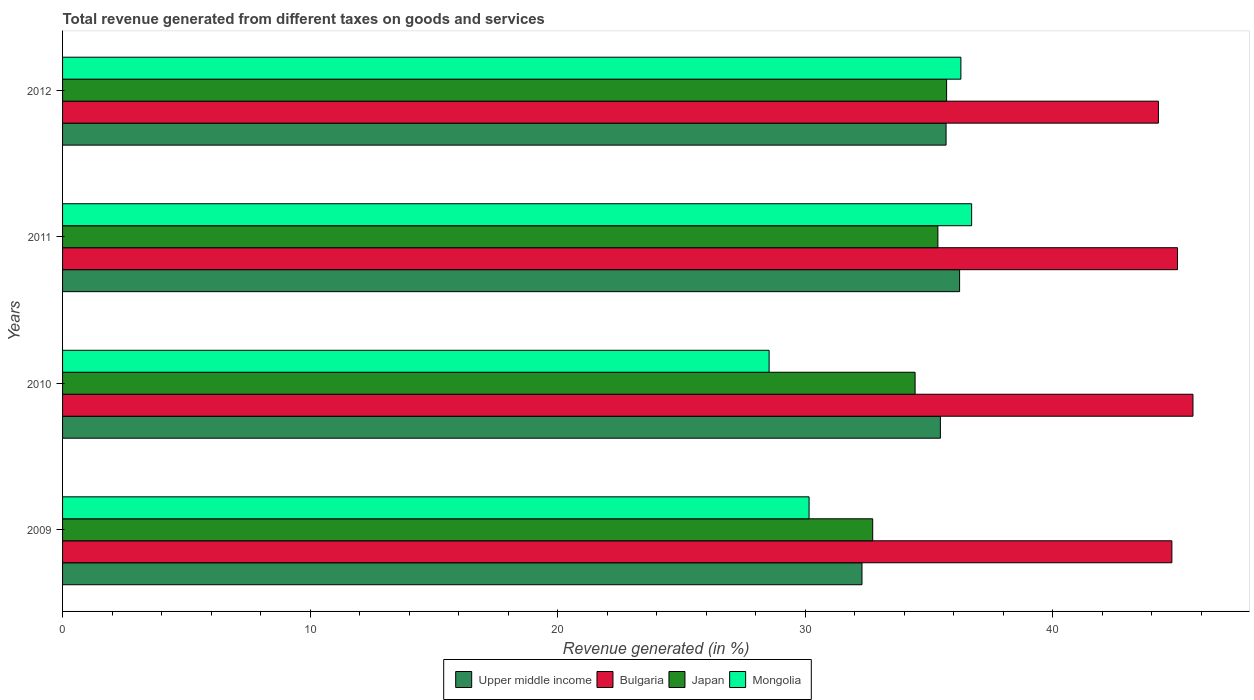How many different coloured bars are there?
Offer a terse response. 4. How many groups of bars are there?
Your answer should be compact. 4. Are the number of bars per tick equal to the number of legend labels?
Offer a very short reply. Yes. Are the number of bars on each tick of the Y-axis equal?
Your response must be concise. Yes. How many bars are there on the 3rd tick from the bottom?
Give a very brief answer. 4. What is the label of the 3rd group of bars from the top?
Offer a terse response. 2010. What is the total revenue generated in Bulgaria in 2010?
Ensure brevity in your answer.  45.67. Across all years, what is the maximum total revenue generated in Upper middle income?
Make the answer very short. 36.24. Across all years, what is the minimum total revenue generated in Upper middle income?
Keep it short and to the point. 32.3. In which year was the total revenue generated in Upper middle income maximum?
Provide a short and direct response. 2011. In which year was the total revenue generated in Upper middle income minimum?
Your answer should be compact. 2009. What is the total total revenue generated in Japan in the graph?
Offer a very short reply. 138.24. What is the difference between the total revenue generated in Bulgaria in 2009 and that in 2010?
Provide a short and direct response. -0.85. What is the difference between the total revenue generated in Mongolia in 2009 and the total revenue generated in Japan in 2011?
Your response must be concise. -5.2. What is the average total revenue generated in Mongolia per year?
Provide a succinct answer. 32.93. In the year 2011, what is the difference between the total revenue generated in Mongolia and total revenue generated in Japan?
Ensure brevity in your answer.  1.36. What is the ratio of the total revenue generated in Japan in 2010 to that in 2012?
Your response must be concise. 0.96. Is the total revenue generated in Bulgaria in 2010 less than that in 2011?
Ensure brevity in your answer.  No. Is the difference between the total revenue generated in Mongolia in 2011 and 2012 greater than the difference between the total revenue generated in Japan in 2011 and 2012?
Keep it short and to the point. Yes. What is the difference between the highest and the second highest total revenue generated in Upper middle income?
Give a very brief answer. 0.55. What is the difference between the highest and the lowest total revenue generated in Bulgaria?
Offer a terse response. 1.4. In how many years, is the total revenue generated in Mongolia greater than the average total revenue generated in Mongolia taken over all years?
Your response must be concise. 2. Is it the case that in every year, the sum of the total revenue generated in Bulgaria and total revenue generated in Japan is greater than the sum of total revenue generated in Mongolia and total revenue generated in Upper middle income?
Make the answer very short. Yes. What does the 2nd bar from the top in 2011 represents?
Provide a short and direct response. Japan. What does the 1st bar from the bottom in 2009 represents?
Your response must be concise. Upper middle income. Are all the bars in the graph horizontal?
Keep it short and to the point. Yes. Are the values on the major ticks of X-axis written in scientific E-notation?
Your response must be concise. No. Where does the legend appear in the graph?
Make the answer very short. Bottom center. How many legend labels are there?
Keep it short and to the point. 4. How are the legend labels stacked?
Keep it short and to the point. Horizontal. What is the title of the graph?
Provide a succinct answer. Total revenue generated from different taxes on goods and services. What is the label or title of the X-axis?
Your answer should be compact. Revenue generated (in %). What is the Revenue generated (in %) in Upper middle income in 2009?
Your answer should be very brief. 32.3. What is the Revenue generated (in %) of Bulgaria in 2009?
Offer a very short reply. 44.81. What is the Revenue generated (in %) in Japan in 2009?
Keep it short and to the point. 32.73. What is the Revenue generated (in %) in Mongolia in 2009?
Offer a very short reply. 30.16. What is the Revenue generated (in %) of Upper middle income in 2010?
Provide a succinct answer. 35.46. What is the Revenue generated (in %) in Bulgaria in 2010?
Offer a very short reply. 45.67. What is the Revenue generated (in %) of Japan in 2010?
Offer a terse response. 34.44. What is the Revenue generated (in %) of Mongolia in 2010?
Your response must be concise. 28.54. What is the Revenue generated (in %) of Upper middle income in 2011?
Give a very brief answer. 36.24. What is the Revenue generated (in %) in Bulgaria in 2011?
Offer a very short reply. 45.04. What is the Revenue generated (in %) in Japan in 2011?
Your response must be concise. 35.36. What is the Revenue generated (in %) of Mongolia in 2011?
Your answer should be compact. 36.73. What is the Revenue generated (in %) in Upper middle income in 2012?
Give a very brief answer. 35.69. What is the Revenue generated (in %) in Bulgaria in 2012?
Keep it short and to the point. 44.27. What is the Revenue generated (in %) in Japan in 2012?
Ensure brevity in your answer.  35.71. What is the Revenue generated (in %) in Mongolia in 2012?
Keep it short and to the point. 36.29. Across all years, what is the maximum Revenue generated (in %) of Upper middle income?
Your response must be concise. 36.24. Across all years, what is the maximum Revenue generated (in %) of Bulgaria?
Your answer should be very brief. 45.67. Across all years, what is the maximum Revenue generated (in %) in Japan?
Your answer should be very brief. 35.71. Across all years, what is the maximum Revenue generated (in %) in Mongolia?
Your answer should be compact. 36.73. Across all years, what is the minimum Revenue generated (in %) in Upper middle income?
Your answer should be very brief. 32.3. Across all years, what is the minimum Revenue generated (in %) in Bulgaria?
Make the answer very short. 44.27. Across all years, what is the minimum Revenue generated (in %) in Japan?
Provide a succinct answer. 32.73. Across all years, what is the minimum Revenue generated (in %) of Mongolia?
Give a very brief answer. 28.54. What is the total Revenue generated (in %) of Upper middle income in the graph?
Offer a terse response. 139.69. What is the total Revenue generated (in %) of Bulgaria in the graph?
Offer a very short reply. 179.79. What is the total Revenue generated (in %) of Japan in the graph?
Your answer should be very brief. 138.24. What is the total Revenue generated (in %) of Mongolia in the graph?
Provide a short and direct response. 131.72. What is the difference between the Revenue generated (in %) in Upper middle income in 2009 and that in 2010?
Offer a terse response. -3.17. What is the difference between the Revenue generated (in %) in Bulgaria in 2009 and that in 2010?
Provide a succinct answer. -0.85. What is the difference between the Revenue generated (in %) in Japan in 2009 and that in 2010?
Your response must be concise. -1.71. What is the difference between the Revenue generated (in %) in Mongolia in 2009 and that in 2010?
Provide a short and direct response. 1.61. What is the difference between the Revenue generated (in %) in Upper middle income in 2009 and that in 2011?
Your answer should be compact. -3.94. What is the difference between the Revenue generated (in %) of Bulgaria in 2009 and that in 2011?
Provide a succinct answer. -0.23. What is the difference between the Revenue generated (in %) in Japan in 2009 and that in 2011?
Provide a succinct answer. -2.63. What is the difference between the Revenue generated (in %) of Mongolia in 2009 and that in 2011?
Provide a succinct answer. -6.57. What is the difference between the Revenue generated (in %) of Upper middle income in 2009 and that in 2012?
Provide a succinct answer. -3.4. What is the difference between the Revenue generated (in %) in Bulgaria in 2009 and that in 2012?
Give a very brief answer. 0.54. What is the difference between the Revenue generated (in %) in Japan in 2009 and that in 2012?
Your answer should be compact. -2.98. What is the difference between the Revenue generated (in %) in Mongolia in 2009 and that in 2012?
Your answer should be very brief. -6.13. What is the difference between the Revenue generated (in %) of Upper middle income in 2010 and that in 2011?
Your response must be concise. -0.78. What is the difference between the Revenue generated (in %) in Bulgaria in 2010 and that in 2011?
Make the answer very short. 0.62. What is the difference between the Revenue generated (in %) in Japan in 2010 and that in 2011?
Make the answer very short. -0.92. What is the difference between the Revenue generated (in %) of Mongolia in 2010 and that in 2011?
Your answer should be compact. -8.18. What is the difference between the Revenue generated (in %) in Upper middle income in 2010 and that in 2012?
Your answer should be very brief. -0.23. What is the difference between the Revenue generated (in %) of Bulgaria in 2010 and that in 2012?
Give a very brief answer. 1.4. What is the difference between the Revenue generated (in %) of Japan in 2010 and that in 2012?
Make the answer very short. -1.27. What is the difference between the Revenue generated (in %) of Mongolia in 2010 and that in 2012?
Your answer should be compact. -7.75. What is the difference between the Revenue generated (in %) of Upper middle income in 2011 and that in 2012?
Ensure brevity in your answer.  0.55. What is the difference between the Revenue generated (in %) in Bulgaria in 2011 and that in 2012?
Give a very brief answer. 0.77. What is the difference between the Revenue generated (in %) of Japan in 2011 and that in 2012?
Your response must be concise. -0.35. What is the difference between the Revenue generated (in %) in Mongolia in 2011 and that in 2012?
Your answer should be very brief. 0.43. What is the difference between the Revenue generated (in %) of Upper middle income in 2009 and the Revenue generated (in %) of Bulgaria in 2010?
Ensure brevity in your answer.  -13.37. What is the difference between the Revenue generated (in %) of Upper middle income in 2009 and the Revenue generated (in %) of Japan in 2010?
Your response must be concise. -2.15. What is the difference between the Revenue generated (in %) in Upper middle income in 2009 and the Revenue generated (in %) in Mongolia in 2010?
Provide a short and direct response. 3.75. What is the difference between the Revenue generated (in %) in Bulgaria in 2009 and the Revenue generated (in %) in Japan in 2010?
Keep it short and to the point. 10.37. What is the difference between the Revenue generated (in %) of Bulgaria in 2009 and the Revenue generated (in %) of Mongolia in 2010?
Provide a succinct answer. 16.27. What is the difference between the Revenue generated (in %) in Japan in 2009 and the Revenue generated (in %) in Mongolia in 2010?
Provide a succinct answer. 4.19. What is the difference between the Revenue generated (in %) of Upper middle income in 2009 and the Revenue generated (in %) of Bulgaria in 2011?
Keep it short and to the point. -12.75. What is the difference between the Revenue generated (in %) of Upper middle income in 2009 and the Revenue generated (in %) of Japan in 2011?
Your response must be concise. -3.07. What is the difference between the Revenue generated (in %) of Upper middle income in 2009 and the Revenue generated (in %) of Mongolia in 2011?
Provide a succinct answer. -4.43. What is the difference between the Revenue generated (in %) in Bulgaria in 2009 and the Revenue generated (in %) in Japan in 2011?
Offer a very short reply. 9.45. What is the difference between the Revenue generated (in %) in Bulgaria in 2009 and the Revenue generated (in %) in Mongolia in 2011?
Provide a short and direct response. 8.09. What is the difference between the Revenue generated (in %) in Japan in 2009 and the Revenue generated (in %) in Mongolia in 2011?
Provide a succinct answer. -4. What is the difference between the Revenue generated (in %) in Upper middle income in 2009 and the Revenue generated (in %) in Bulgaria in 2012?
Make the answer very short. -11.98. What is the difference between the Revenue generated (in %) of Upper middle income in 2009 and the Revenue generated (in %) of Japan in 2012?
Provide a short and direct response. -3.42. What is the difference between the Revenue generated (in %) in Upper middle income in 2009 and the Revenue generated (in %) in Mongolia in 2012?
Give a very brief answer. -4. What is the difference between the Revenue generated (in %) of Bulgaria in 2009 and the Revenue generated (in %) of Japan in 2012?
Make the answer very short. 9.1. What is the difference between the Revenue generated (in %) of Bulgaria in 2009 and the Revenue generated (in %) of Mongolia in 2012?
Offer a very short reply. 8.52. What is the difference between the Revenue generated (in %) of Japan in 2009 and the Revenue generated (in %) of Mongolia in 2012?
Offer a terse response. -3.56. What is the difference between the Revenue generated (in %) in Upper middle income in 2010 and the Revenue generated (in %) in Bulgaria in 2011?
Your answer should be very brief. -9.58. What is the difference between the Revenue generated (in %) of Upper middle income in 2010 and the Revenue generated (in %) of Japan in 2011?
Your response must be concise. 0.1. What is the difference between the Revenue generated (in %) of Upper middle income in 2010 and the Revenue generated (in %) of Mongolia in 2011?
Provide a succinct answer. -1.26. What is the difference between the Revenue generated (in %) in Bulgaria in 2010 and the Revenue generated (in %) in Japan in 2011?
Provide a succinct answer. 10.31. What is the difference between the Revenue generated (in %) in Bulgaria in 2010 and the Revenue generated (in %) in Mongolia in 2011?
Give a very brief answer. 8.94. What is the difference between the Revenue generated (in %) of Japan in 2010 and the Revenue generated (in %) of Mongolia in 2011?
Provide a succinct answer. -2.28. What is the difference between the Revenue generated (in %) of Upper middle income in 2010 and the Revenue generated (in %) of Bulgaria in 2012?
Your answer should be compact. -8.81. What is the difference between the Revenue generated (in %) of Upper middle income in 2010 and the Revenue generated (in %) of Japan in 2012?
Your answer should be very brief. -0.25. What is the difference between the Revenue generated (in %) of Upper middle income in 2010 and the Revenue generated (in %) of Mongolia in 2012?
Keep it short and to the point. -0.83. What is the difference between the Revenue generated (in %) in Bulgaria in 2010 and the Revenue generated (in %) in Japan in 2012?
Provide a succinct answer. 9.95. What is the difference between the Revenue generated (in %) of Bulgaria in 2010 and the Revenue generated (in %) of Mongolia in 2012?
Ensure brevity in your answer.  9.38. What is the difference between the Revenue generated (in %) in Japan in 2010 and the Revenue generated (in %) in Mongolia in 2012?
Offer a very short reply. -1.85. What is the difference between the Revenue generated (in %) in Upper middle income in 2011 and the Revenue generated (in %) in Bulgaria in 2012?
Provide a short and direct response. -8.03. What is the difference between the Revenue generated (in %) of Upper middle income in 2011 and the Revenue generated (in %) of Japan in 2012?
Your answer should be very brief. 0.53. What is the difference between the Revenue generated (in %) in Upper middle income in 2011 and the Revenue generated (in %) in Mongolia in 2012?
Offer a terse response. -0.05. What is the difference between the Revenue generated (in %) in Bulgaria in 2011 and the Revenue generated (in %) in Japan in 2012?
Offer a very short reply. 9.33. What is the difference between the Revenue generated (in %) in Bulgaria in 2011 and the Revenue generated (in %) in Mongolia in 2012?
Provide a succinct answer. 8.75. What is the difference between the Revenue generated (in %) of Japan in 2011 and the Revenue generated (in %) of Mongolia in 2012?
Provide a short and direct response. -0.93. What is the average Revenue generated (in %) in Upper middle income per year?
Your answer should be very brief. 34.92. What is the average Revenue generated (in %) in Bulgaria per year?
Your response must be concise. 44.95. What is the average Revenue generated (in %) of Japan per year?
Give a very brief answer. 34.56. What is the average Revenue generated (in %) in Mongolia per year?
Your response must be concise. 32.93. In the year 2009, what is the difference between the Revenue generated (in %) in Upper middle income and Revenue generated (in %) in Bulgaria?
Make the answer very short. -12.52. In the year 2009, what is the difference between the Revenue generated (in %) in Upper middle income and Revenue generated (in %) in Japan?
Provide a succinct answer. -0.43. In the year 2009, what is the difference between the Revenue generated (in %) in Upper middle income and Revenue generated (in %) in Mongolia?
Ensure brevity in your answer.  2.14. In the year 2009, what is the difference between the Revenue generated (in %) in Bulgaria and Revenue generated (in %) in Japan?
Ensure brevity in your answer.  12.09. In the year 2009, what is the difference between the Revenue generated (in %) of Bulgaria and Revenue generated (in %) of Mongolia?
Keep it short and to the point. 14.66. In the year 2009, what is the difference between the Revenue generated (in %) in Japan and Revenue generated (in %) in Mongolia?
Keep it short and to the point. 2.57. In the year 2010, what is the difference between the Revenue generated (in %) of Upper middle income and Revenue generated (in %) of Bulgaria?
Your answer should be compact. -10.2. In the year 2010, what is the difference between the Revenue generated (in %) of Upper middle income and Revenue generated (in %) of Japan?
Give a very brief answer. 1.02. In the year 2010, what is the difference between the Revenue generated (in %) in Upper middle income and Revenue generated (in %) in Mongolia?
Your response must be concise. 6.92. In the year 2010, what is the difference between the Revenue generated (in %) of Bulgaria and Revenue generated (in %) of Japan?
Give a very brief answer. 11.23. In the year 2010, what is the difference between the Revenue generated (in %) of Bulgaria and Revenue generated (in %) of Mongolia?
Give a very brief answer. 17.12. In the year 2010, what is the difference between the Revenue generated (in %) in Japan and Revenue generated (in %) in Mongolia?
Your answer should be compact. 5.9. In the year 2011, what is the difference between the Revenue generated (in %) of Upper middle income and Revenue generated (in %) of Bulgaria?
Give a very brief answer. -8.8. In the year 2011, what is the difference between the Revenue generated (in %) in Upper middle income and Revenue generated (in %) in Japan?
Offer a very short reply. 0.88. In the year 2011, what is the difference between the Revenue generated (in %) in Upper middle income and Revenue generated (in %) in Mongolia?
Offer a terse response. -0.49. In the year 2011, what is the difference between the Revenue generated (in %) of Bulgaria and Revenue generated (in %) of Japan?
Your response must be concise. 9.68. In the year 2011, what is the difference between the Revenue generated (in %) in Bulgaria and Revenue generated (in %) in Mongolia?
Offer a very short reply. 8.32. In the year 2011, what is the difference between the Revenue generated (in %) in Japan and Revenue generated (in %) in Mongolia?
Keep it short and to the point. -1.36. In the year 2012, what is the difference between the Revenue generated (in %) of Upper middle income and Revenue generated (in %) of Bulgaria?
Provide a short and direct response. -8.58. In the year 2012, what is the difference between the Revenue generated (in %) of Upper middle income and Revenue generated (in %) of Japan?
Provide a short and direct response. -0.02. In the year 2012, what is the difference between the Revenue generated (in %) of Upper middle income and Revenue generated (in %) of Mongolia?
Ensure brevity in your answer.  -0.6. In the year 2012, what is the difference between the Revenue generated (in %) of Bulgaria and Revenue generated (in %) of Japan?
Offer a terse response. 8.56. In the year 2012, what is the difference between the Revenue generated (in %) of Bulgaria and Revenue generated (in %) of Mongolia?
Your answer should be compact. 7.98. In the year 2012, what is the difference between the Revenue generated (in %) in Japan and Revenue generated (in %) in Mongolia?
Your answer should be compact. -0.58. What is the ratio of the Revenue generated (in %) of Upper middle income in 2009 to that in 2010?
Your response must be concise. 0.91. What is the ratio of the Revenue generated (in %) of Bulgaria in 2009 to that in 2010?
Offer a very short reply. 0.98. What is the ratio of the Revenue generated (in %) of Japan in 2009 to that in 2010?
Provide a succinct answer. 0.95. What is the ratio of the Revenue generated (in %) in Mongolia in 2009 to that in 2010?
Make the answer very short. 1.06. What is the ratio of the Revenue generated (in %) of Upper middle income in 2009 to that in 2011?
Provide a succinct answer. 0.89. What is the ratio of the Revenue generated (in %) of Japan in 2009 to that in 2011?
Offer a terse response. 0.93. What is the ratio of the Revenue generated (in %) of Mongolia in 2009 to that in 2011?
Offer a terse response. 0.82. What is the ratio of the Revenue generated (in %) of Upper middle income in 2009 to that in 2012?
Your answer should be very brief. 0.9. What is the ratio of the Revenue generated (in %) of Bulgaria in 2009 to that in 2012?
Your response must be concise. 1.01. What is the ratio of the Revenue generated (in %) of Japan in 2009 to that in 2012?
Keep it short and to the point. 0.92. What is the ratio of the Revenue generated (in %) of Mongolia in 2009 to that in 2012?
Your answer should be compact. 0.83. What is the ratio of the Revenue generated (in %) of Upper middle income in 2010 to that in 2011?
Ensure brevity in your answer.  0.98. What is the ratio of the Revenue generated (in %) of Bulgaria in 2010 to that in 2011?
Your response must be concise. 1.01. What is the ratio of the Revenue generated (in %) in Mongolia in 2010 to that in 2011?
Provide a succinct answer. 0.78. What is the ratio of the Revenue generated (in %) of Upper middle income in 2010 to that in 2012?
Provide a succinct answer. 0.99. What is the ratio of the Revenue generated (in %) in Bulgaria in 2010 to that in 2012?
Your answer should be compact. 1.03. What is the ratio of the Revenue generated (in %) of Japan in 2010 to that in 2012?
Make the answer very short. 0.96. What is the ratio of the Revenue generated (in %) of Mongolia in 2010 to that in 2012?
Provide a succinct answer. 0.79. What is the ratio of the Revenue generated (in %) of Upper middle income in 2011 to that in 2012?
Your response must be concise. 1.02. What is the ratio of the Revenue generated (in %) of Bulgaria in 2011 to that in 2012?
Offer a very short reply. 1.02. What is the ratio of the Revenue generated (in %) in Japan in 2011 to that in 2012?
Keep it short and to the point. 0.99. What is the difference between the highest and the second highest Revenue generated (in %) of Upper middle income?
Offer a very short reply. 0.55. What is the difference between the highest and the second highest Revenue generated (in %) in Bulgaria?
Your answer should be compact. 0.62. What is the difference between the highest and the second highest Revenue generated (in %) in Japan?
Provide a short and direct response. 0.35. What is the difference between the highest and the second highest Revenue generated (in %) of Mongolia?
Your answer should be very brief. 0.43. What is the difference between the highest and the lowest Revenue generated (in %) in Upper middle income?
Your answer should be compact. 3.94. What is the difference between the highest and the lowest Revenue generated (in %) in Bulgaria?
Provide a succinct answer. 1.4. What is the difference between the highest and the lowest Revenue generated (in %) of Japan?
Offer a very short reply. 2.98. What is the difference between the highest and the lowest Revenue generated (in %) in Mongolia?
Ensure brevity in your answer.  8.18. 